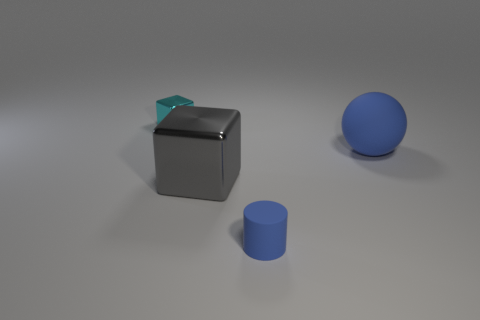Add 2 purple metal objects. How many objects exist? 6 Subtract all large purple metal things. Subtract all big gray cubes. How many objects are left? 3 Add 1 big gray blocks. How many big gray blocks are left? 2 Add 1 blue objects. How many blue objects exist? 3 Subtract 0 blue cubes. How many objects are left? 4 